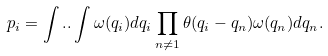<formula> <loc_0><loc_0><loc_500><loc_500>p _ { i } = \int . . \int \omega ( q _ { i } ) d q _ { i } \prod _ { n \neq 1 } \theta ( q _ { i } - q _ { n } ) \omega ( q _ { n } ) d q _ { n } .</formula> 